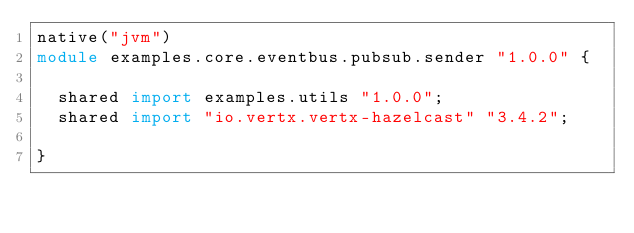<code> <loc_0><loc_0><loc_500><loc_500><_Ceylon_>native("jvm")
module examples.core.eventbus.pubsub.sender "1.0.0" {
  
  shared import examples.utils "1.0.0";
  shared import "io.vertx.vertx-hazelcast" "3.4.2";
  
}
</code> 